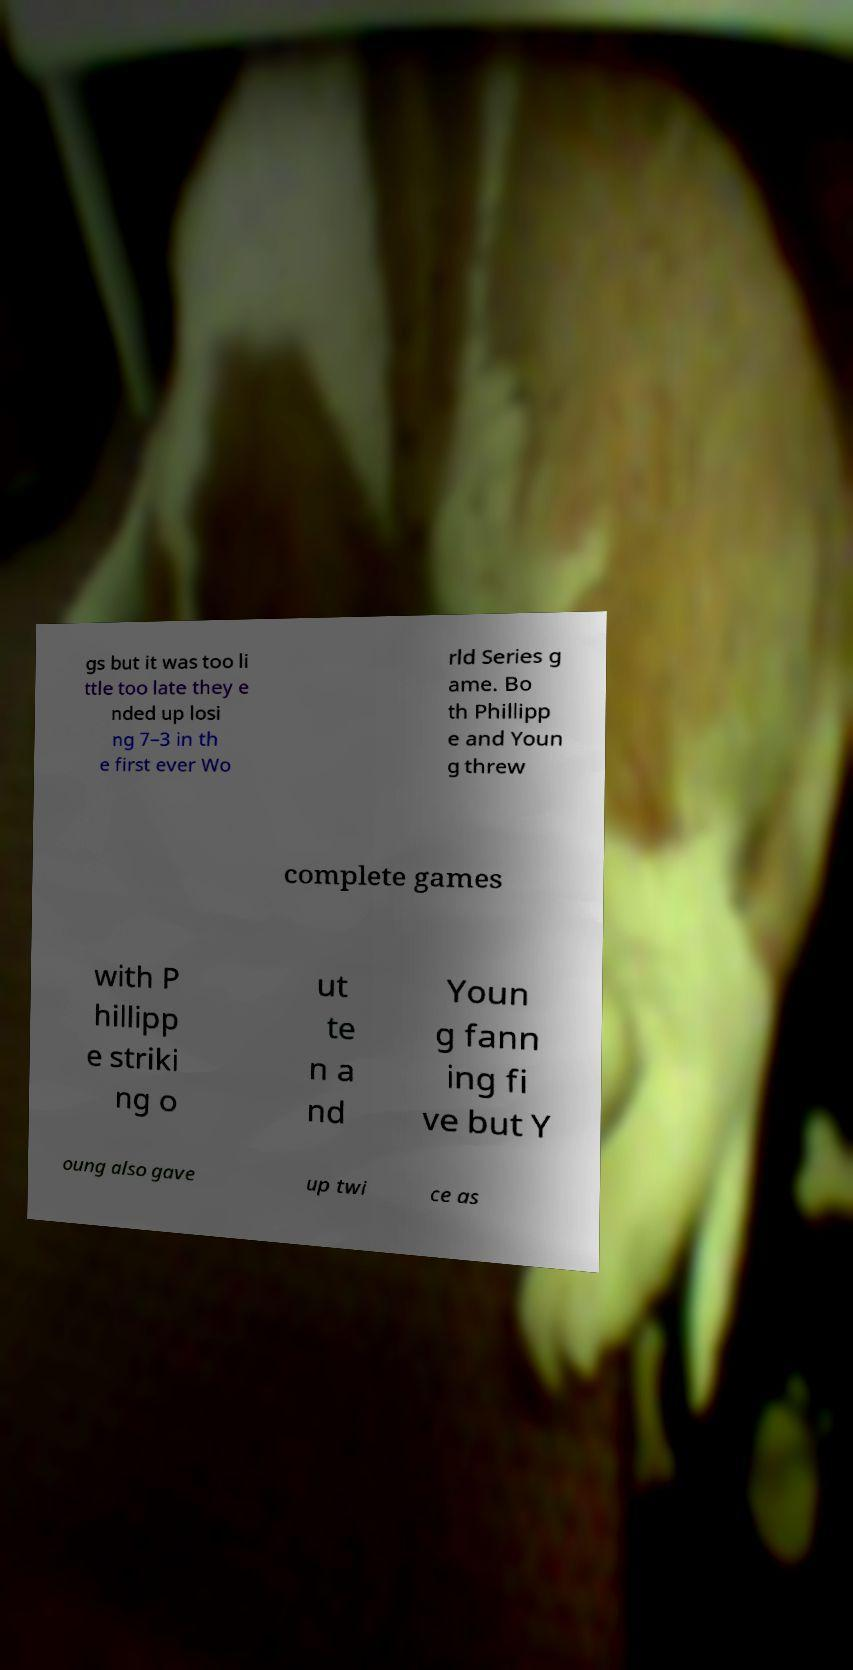Could you assist in decoding the text presented in this image and type it out clearly? gs but it was too li ttle too late they e nded up losi ng 7–3 in th e first ever Wo rld Series g ame. Bo th Phillipp e and Youn g threw complete games with P hillipp e striki ng o ut te n a nd Youn g fann ing fi ve but Y oung also gave up twi ce as 